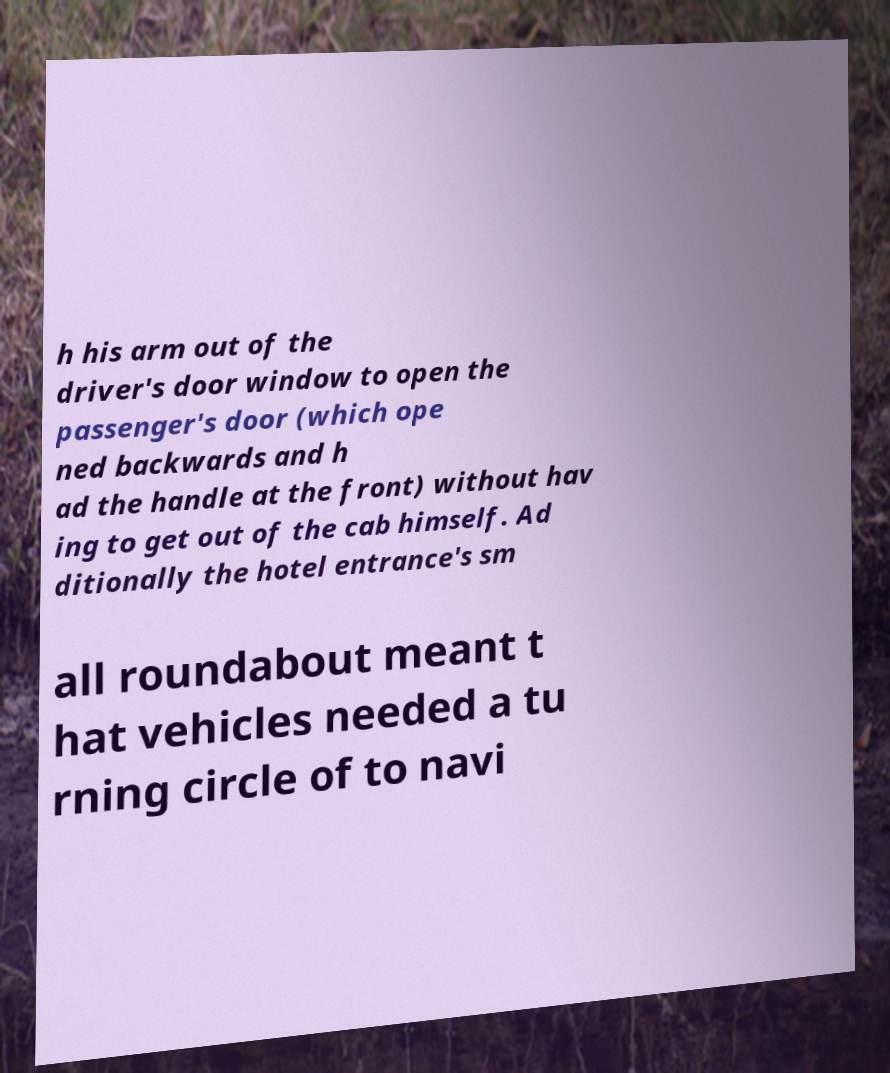What messages or text are displayed in this image? I need them in a readable, typed format. h his arm out of the driver's door window to open the passenger's door (which ope ned backwards and h ad the handle at the front) without hav ing to get out of the cab himself. Ad ditionally the hotel entrance's sm all roundabout meant t hat vehicles needed a tu rning circle of to navi 